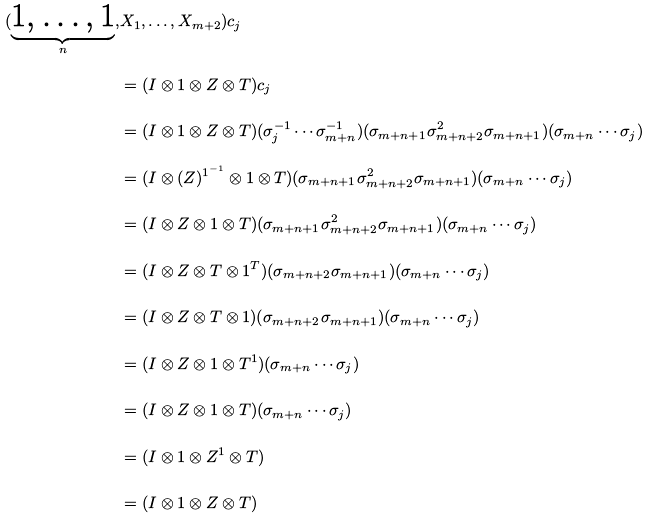<formula> <loc_0><loc_0><loc_500><loc_500>( \underbrace { 1 , \dots , 1 } _ { n } , & X _ { 1 } , \dots , X _ { m + 2 } ) c _ { j } \\ & = ( I \otimes 1 \otimes Z \otimes T ) c _ { j } \\ & = ( I \otimes 1 \otimes Z \otimes T ) ( \sigma _ { j } ^ { - 1 } \cdots \sigma _ { m + n } ^ { - 1 } ) ( \sigma _ { m + n + 1 } \sigma _ { m + n + 2 } ^ { 2 } \sigma _ { m + n + 1 } ) ( \sigma _ { m + n } \cdots \sigma _ { j } ) \\ & = ( I \otimes ( Z ) ^ { 1 ^ { - 1 } } \otimes 1 \otimes T ) ( \sigma _ { m + n + 1 } \sigma _ { m + n + 2 } ^ { 2 } \sigma _ { m + n + 1 } ) ( \sigma _ { m + n } \cdots \sigma _ { j } ) \\ & = ( I \otimes Z \otimes 1 \otimes T ) ( \sigma _ { m + n + 1 } \sigma _ { m + n + 2 } ^ { 2 } \sigma _ { m + n + 1 } ) ( \sigma _ { m + n } \cdots \sigma _ { j } ) \\ & = ( I \otimes Z \otimes T \otimes 1 ^ { T } ) ( \sigma _ { m + n + 2 } \sigma _ { m + n + 1 } ) ( \sigma _ { m + n } \cdots \sigma _ { j } ) \\ & = ( I \otimes Z \otimes T \otimes 1 ) ( \sigma _ { m + n + 2 } \sigma _ { m + n + 1 } ) ( \sigma _ { m + n } \cdots \sigma _ { j } ) \\ & = ( I \otimes Z \otimes 1 \otimes T ^ { 1 } ) ( \sigma _ { m + n } \cdots \sigma _ { j } ) \\ & = ( I \otimes Z \otimes 1 \otimes T ) ( \sigma _ { m + n } \cdots \sigma _ { j } ) \\ & = ( I \otimes 1 \otimes Z ^ { 1 } \otimes T ) \\ & = ( I \otimes 1 \otimes Z \otimes T )</formula> 